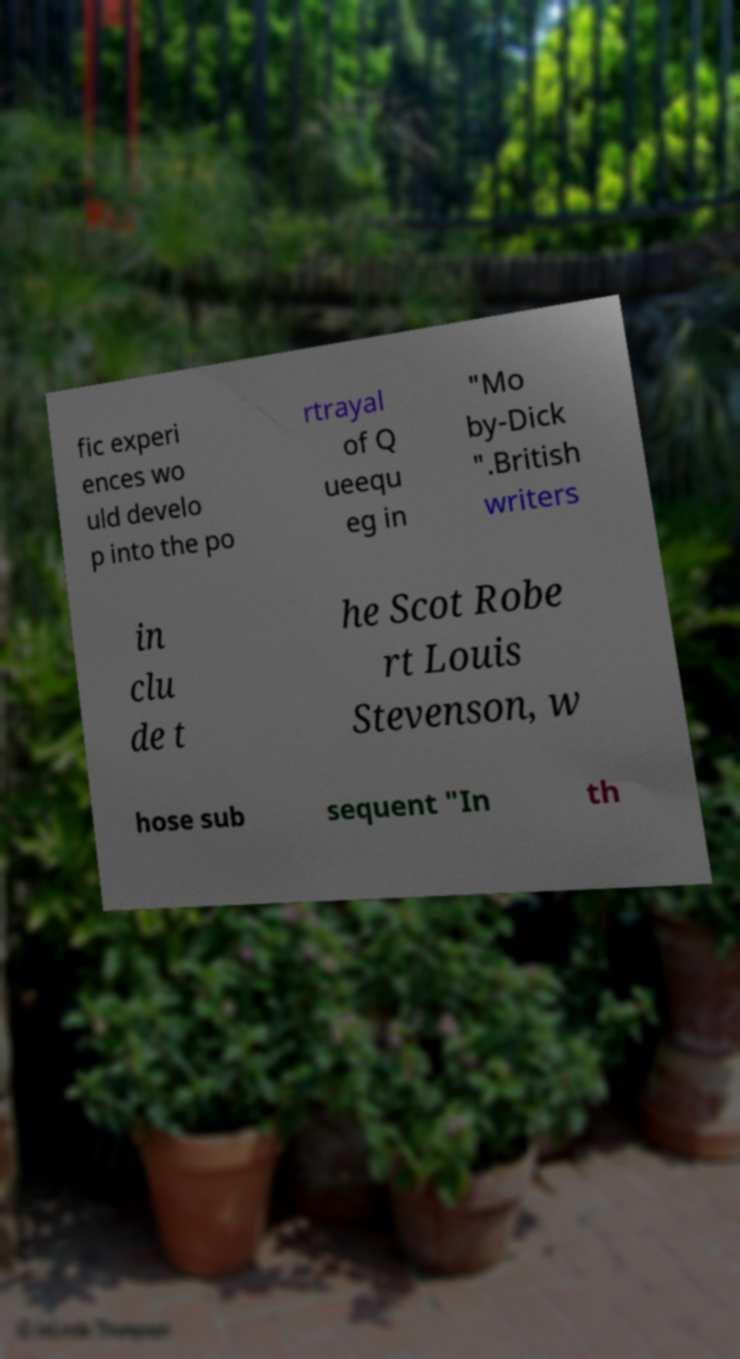There's text embedded in this image that I need extracted. Can you transcribe it verbatim? fic experi ences wo uld develo p into the po rtrayal of Q ueequ eg in "Mo by-Dick ".British writers in clu de t he Scot Robe rt Louis Stevenson, w hose sub sequent "In th 